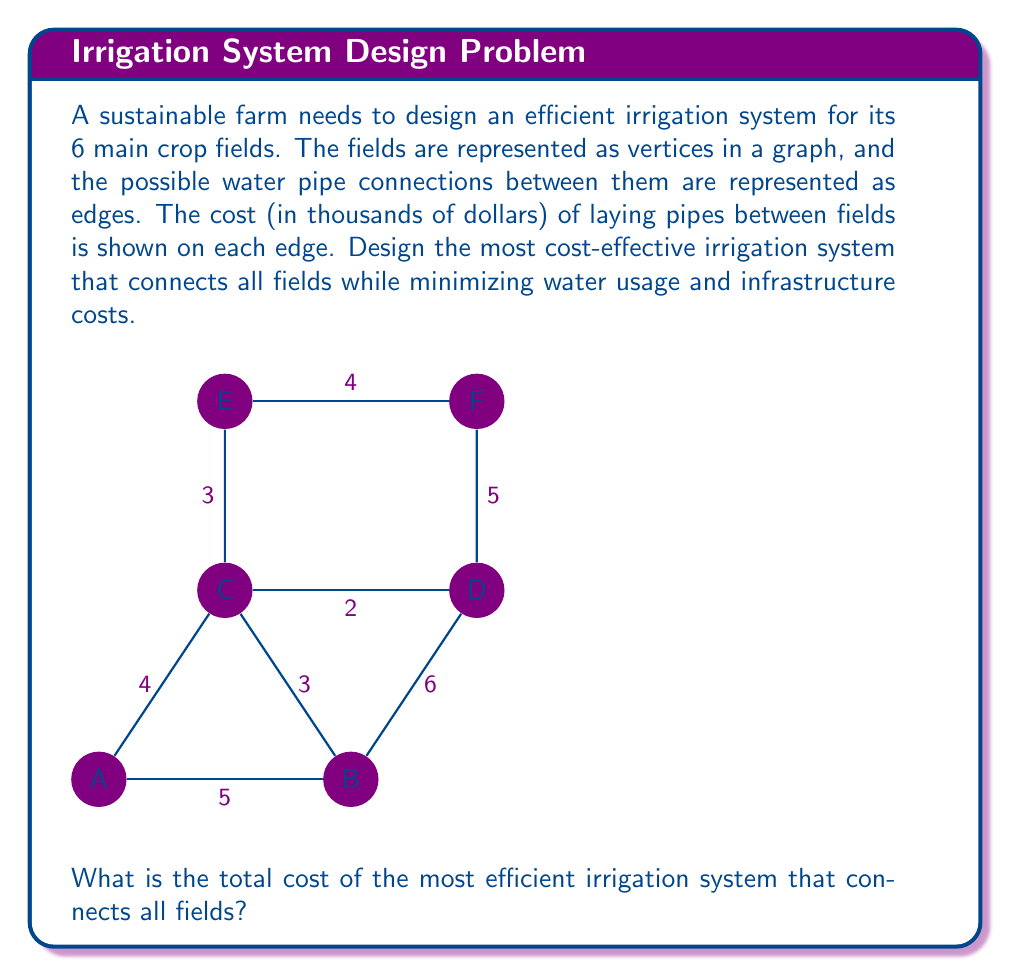Teach me how to tackle this problem. To find the most efficient irrigation system that connects all fields while minimizing costs, we need to find the Minimum Spanning Tree (MST) of the given graph. The MST will ensure that all fields are connected with the minimum total pipe length (and thus, minimum cost).

We can use Kruskal's algorithm to find the MST:

1. Sort all edges by weight (cost) in ascending order:
   CD (2), CE (3), BC (3), AB (5), EF (4), AC (4), BD (6), DF (5)

2. Start with an empty set of edges and add edges one by one, ensuring no cycles are formed:

   - Add CD (2)
   - Add CE (3)
   - Add BC (3)
   - Skip AB (5) as it would form a cycle
   - Add EF (4)
   - Skip AC (4) as it would form a cycle
   - Skip BD (6) as it would form a cycle
   - Skip DF (5) as it would form a cycle

3. The resulting MST consists of the edges: CD, CE, BC, and EF

4. Calculate the total cost:
   $$\text{Total Cost} = 2 + 3 + 3 + 4 = 12$$

Therefore, the most efficient irrigation system that connects all fields has a total cost of 12 thousand dollars.
Answer: $12,000 